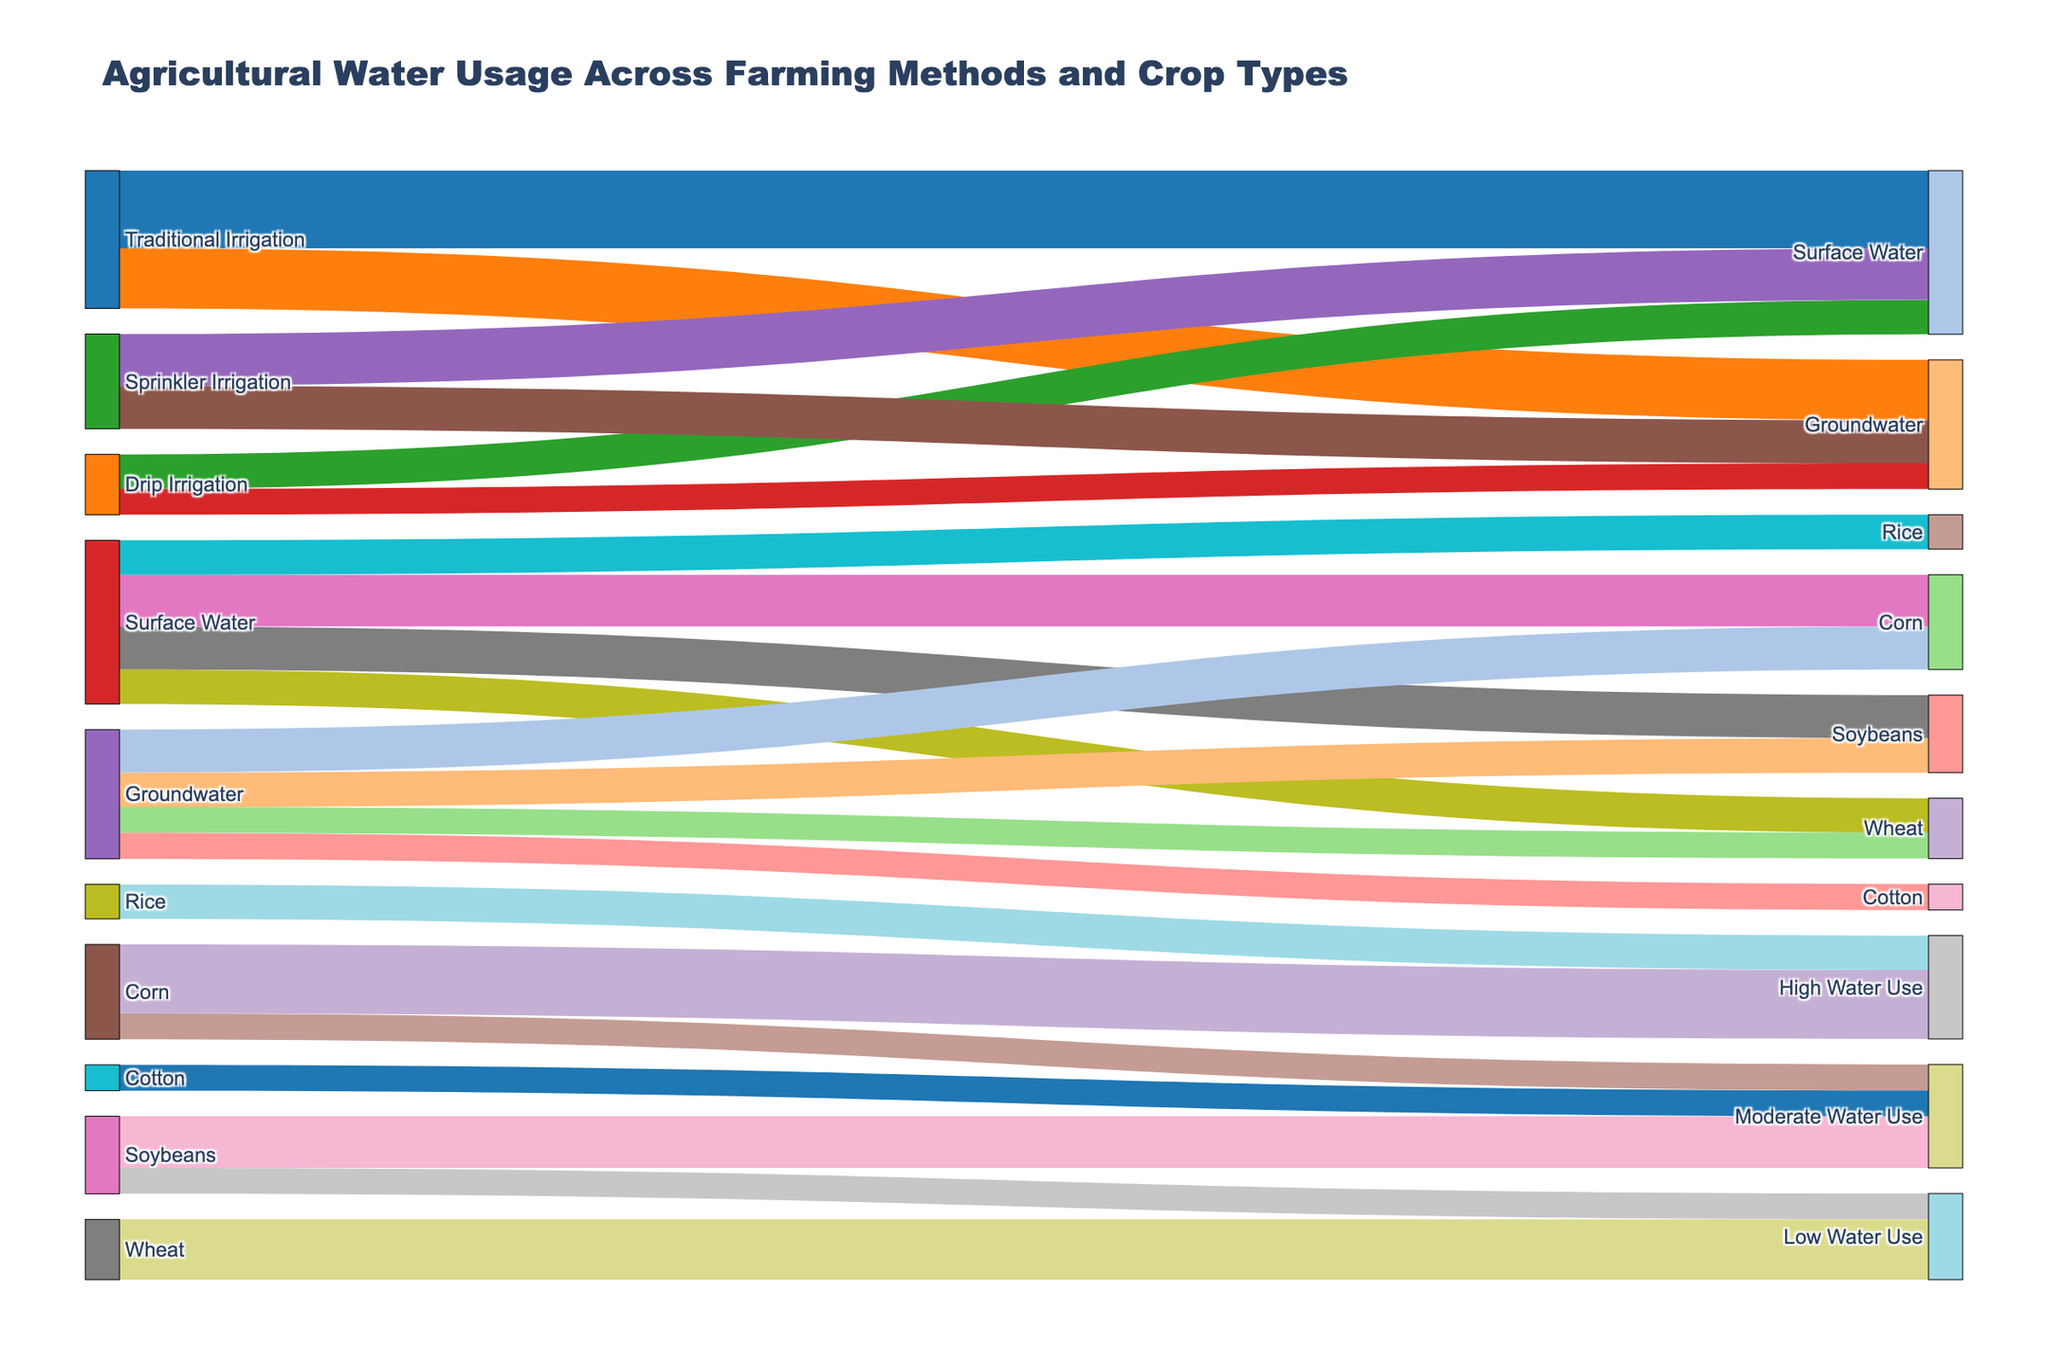What is the title of the Sankey diagram? The title is found at the top of the diagram. It indicates the subject of the visualization.
Answer: Agricultural Water Usage Across Farming Methods and Crop Types How many farming methods are shown in the Sankey diagram? To find the number of farming methods, count the unique entries under the Source column that refer to irrigation practices.
Answer: Three Which farming method uses the most surface water? To determine which method uses the most surface water, compare the values for Surface Water under Traditional Irrigation, Drip Irrigation, and Sprinkler Irrigation.
Answer: Traditional Irrigation What is the total amount of groundwater used by all farming methods combined? Add up the groundwater amounts used by Traditional Irrigation, Drip Irrigation, and Sprinkler Irrigation. 350 + 150 + 250.
Answer: 750 Which crop type has the highest total water usage? To find the crop type with the highest water usage, sum the values for both surface water and groundwater for each crop type. The highest sum indicates the most water usage.
Answer: Corn Which irrigation type contributes the least to rice water usage? Compare the contributions of surface water and groundwater to the rice node. Check which has the smaller value.
Answer: Surface Water Which crop has the most moderate water use? Check the values under Moderate Water Use and identify which crop contributes the most to this category. Soybeans are linked to 300 units.
Answer: Soybeans What is the primary water source for corn based on the diagram? Examine the links leading to Corn and find the one with the highest value from Surface Water or Groundwater.
Answer: Surface Water Among Soybeans and Wheat, which shows a lower water usage from groundwater? Compare the groundwater values for Soybeans and Wheat to determine which one has the lower value.
Answer: Wheat How does the water usage via Drip Irrigation for surface water compare to Traditional Irrigation? Check the Sankey links from Drip Irrigation and Traditional Irrigation to Surface Water, then compare the corresponding values.
Answer: Drip Irrigation uses less water 